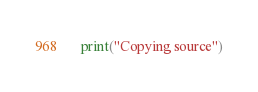Convert code to text. <code><loc_0><loc_0><loc_500><loc_500><_Python_>
  print("Copying source")</code> 